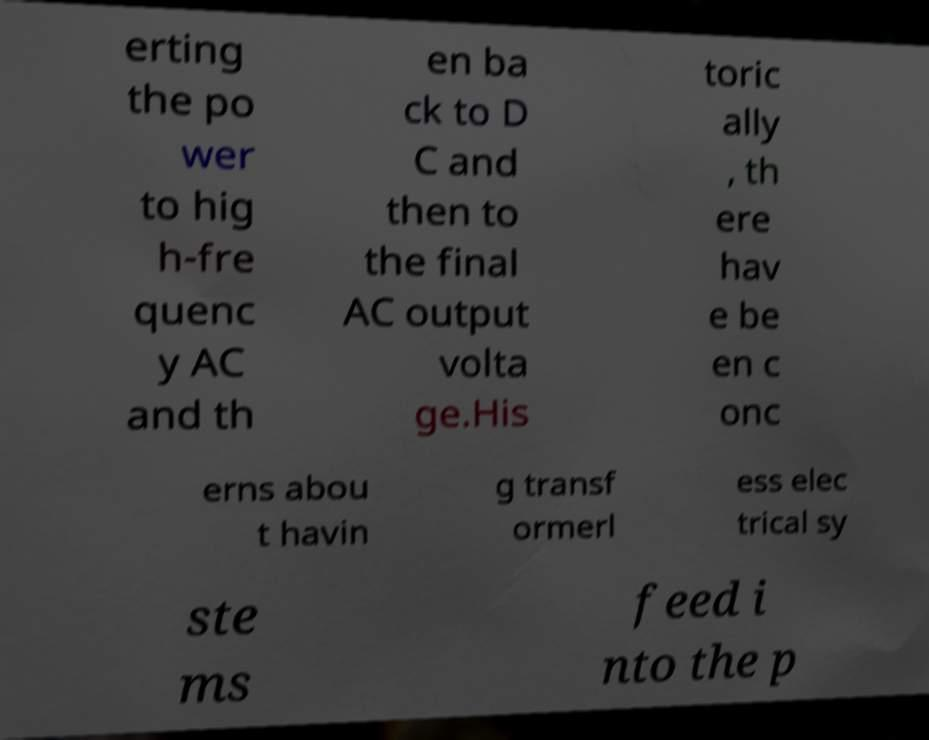Please read and relay the text visible in this image. What does it say? erting the po wer to hig h-fre quenc y AC and th en ba ck to D C and then to the final AC output volta ge.His toric ally , th ere hav e be en c onc erns abou t havin g transf ormerl ess elec trical sy ste ms feed i nto the p 